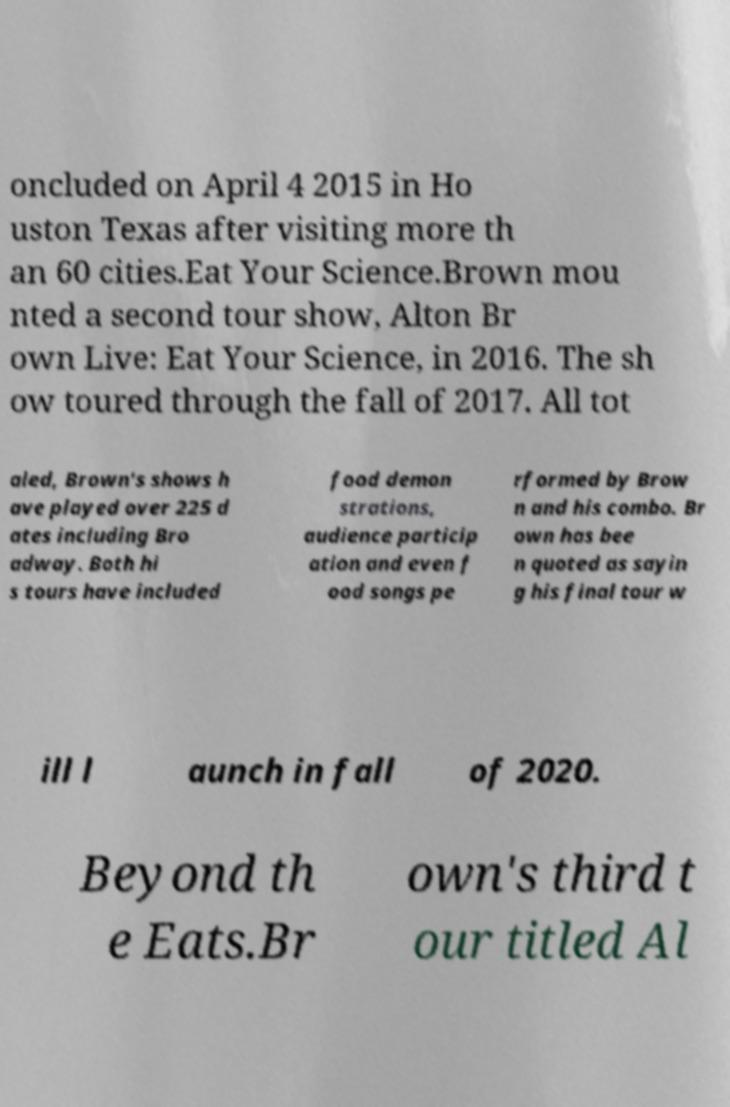Could you extract and type out the text from this image? oncluded on April 4 2015 in Ho uston Texas after visiting more th an 60 cities.Eat Your Science.Brown mou nted a second tour show, Alton Br own Live: Eat Your Science, in 2016. The sh ow toured through the fall of 2017. All tot aled, Brown's shows h ave played over 225 d ates including Bro adway. Both hi s tours have included food demon strations, audience particip ation and even f ood songs pe rformed by Brow n and his combo. Br own has bee n quoted as sayin g his final tour w ill l aunch in fall of 2020. Beyond th e Eats.Br own's third t our titled Al 